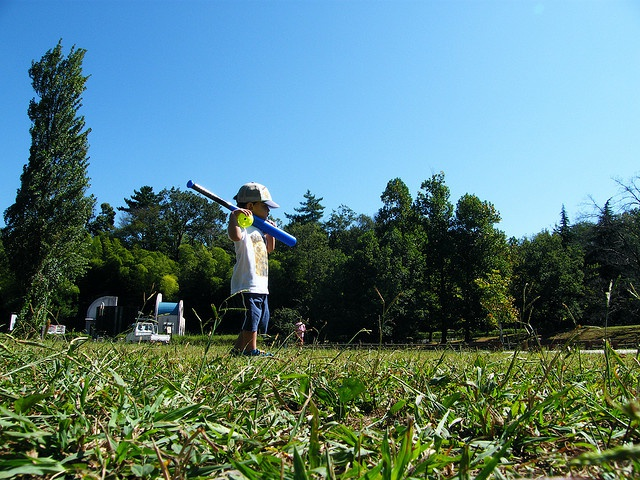Describe the objects in this image and their specific colors. I can see people in gray, black, white, and navy tones, baseball bat in gray, navy, black, darkblue, and white tones, truck in gray, lightgray, black, and darkgray tones, people in blue, black, gray, darkgreen, and lavender tones, and sports ball in gray, olive, khaki, and yellow tones in this image. 